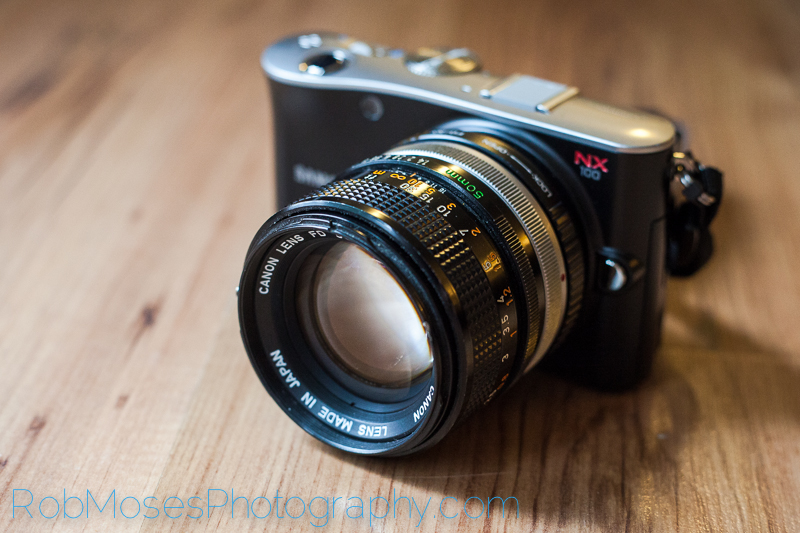What might be the implications of using a Canon FD lens on a sharegpt4v/samsung NX body in terms of functionality and compatibility? Using a Canon FD lens on a sharegpt4v/samsung NX body implies that an adapter is being used because the two systems have different lens mounts and are not directly compatible. In terms of functionality, expect to use manual focus and manual aperture control since FD lenses lack electronic contacts necessary for autofocus or aperture control by the camera body. However, this setup can be particularly appealing to photographers who appreciate the craftsmanship and unique optical characteristics of vintage FD lenses. The combination allows for the creation of a unique visual aesthetic, blending the heritage and character of classic lenses with the advanced features of a modern digital camera body. 